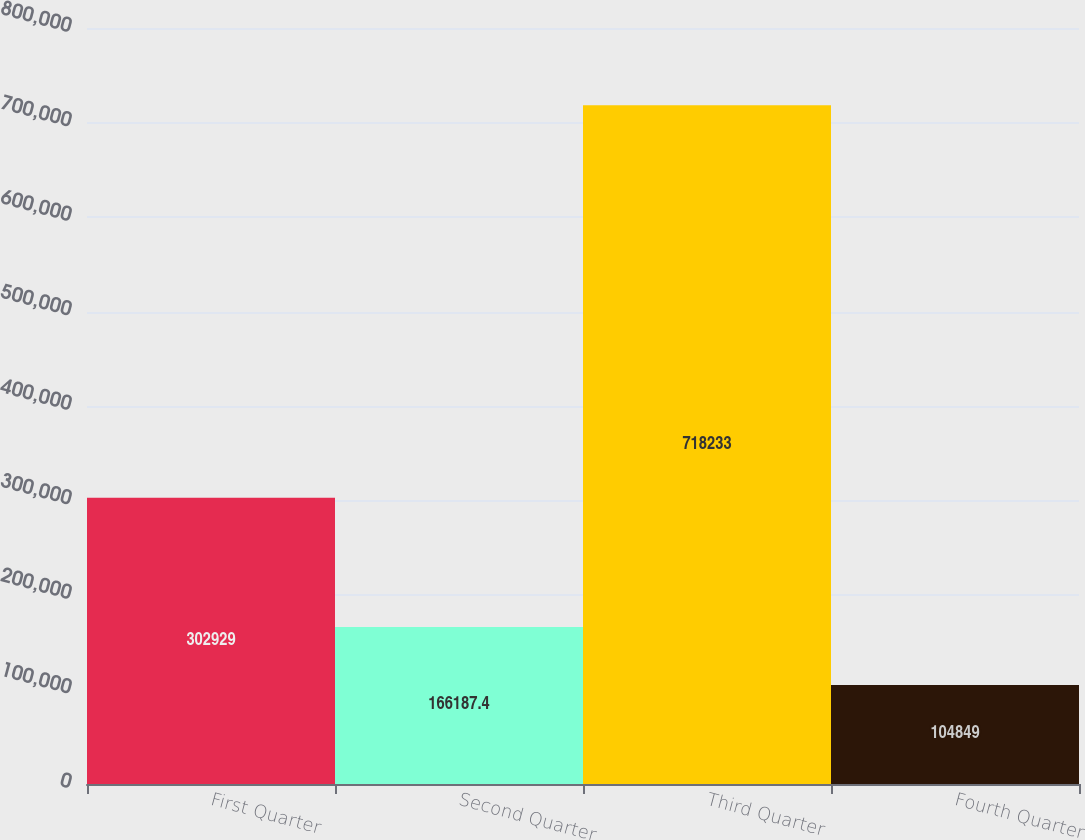Convert chart. <chart><loc_0><loc_0><loc_500><loc_500><bar_chart><fcel>First Quarter<fcel>Second Quarter<fcel>Third Quarter<fcel>Fourth Quarter<nl><fcel>302929<fcel>166187<fcel>718233<fcel>104849<nl></chart> 